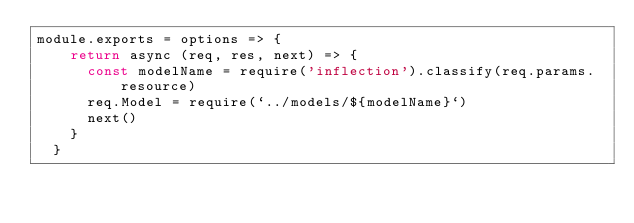<code> <loc_0><loc_0><loc_500><loc_500><_JavaScript_>module.exports = options => {
    return async (req, res, next) => {
      const modelName = require('inflection').classify(req.params.resource)
      req.Model = require(`../models/${modelName}`)
      next()
    }
  }</code> 